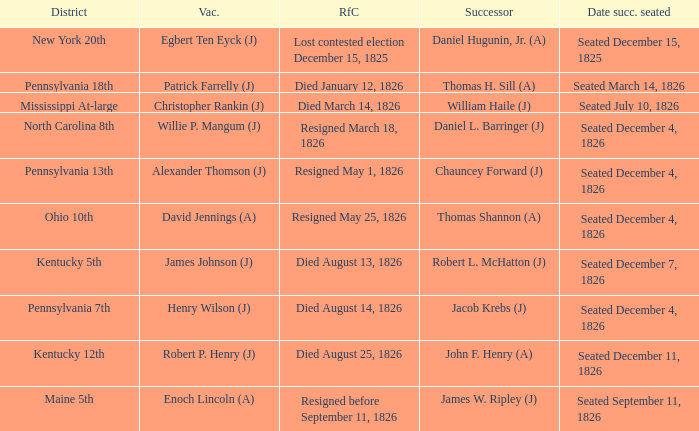Parse the table in full. {'header': ['District', 'Vac.', 'RfC', 'Successor', 'Date succ. seated'], 'rows': [['New York 20th', 'Egbert Ten Eyck (J)', 'Lost contested election December 15, 1825', 'Daniel Hugunin, Jr. (A)', 'Seated December 15, 1825'], ['Pennsylvania 18th', 'Patrick Farrelly (J)', 'Died January 12, 1826', 'Thomas H. Sill (A)', 'Seated March 14, 1826'], ['Mississippi At-large', 'Christopher Rankin (J)', 'Died March 14, 1826', 'William Haile (J)', 'Seated July 10, 1826'], ['North Carolina 8th', 'Willie P. Mangum (J)', 'Resigned March 18, 1826', 'Daniel L. Barringer (J)', 'Seated December 4, 1826'], ['Pennsylvania 13th', 'Alexander Thomson (J)', 'Resigned May 1, 1826', 'Chauncey Forward (J)', 'Seated December 4, 1826'], ['Ohio 10th', 'David Jennings (A)', 'Resigned May 25, 1826', 'Thomas Shannon (A)', 'Seated December 4, 1826'], ['Kentucky 5th', 'James Johnson (J)', 'Died August 13, 1826', 'Robert L. McHatton (J)', 'Seated December 7, 1826'], ['Pennsylvania 7th', 'Henry Wilson (J)', 'Died August 14, 1826', 'Jacob Krebs (J)', 'Seated December 4, 1826'], ['Kentucky 12th', 'Robert P. Henry (J)', 'Died August 25, 1826', 'John F. Henry (A)', 'Seated December 11, 1826'], ['Maine 5th', 'Enoch Lincoln (A)', 'Resigned before September 11, 1826', 'James W. Ripley (J)', 'Seated September 11, 1826']]} Name the vacator for reason for change died january 12, 1826 Patrick Farrelly (J). 